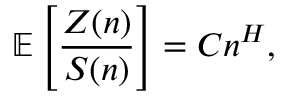<formula> <loc_0><loc_0><loc_500><loc_500>\mathbb { E } \left [ \frac { Z ( n ) } { S ( n ) } \right ] = C n ^ { H } ,</formula> 